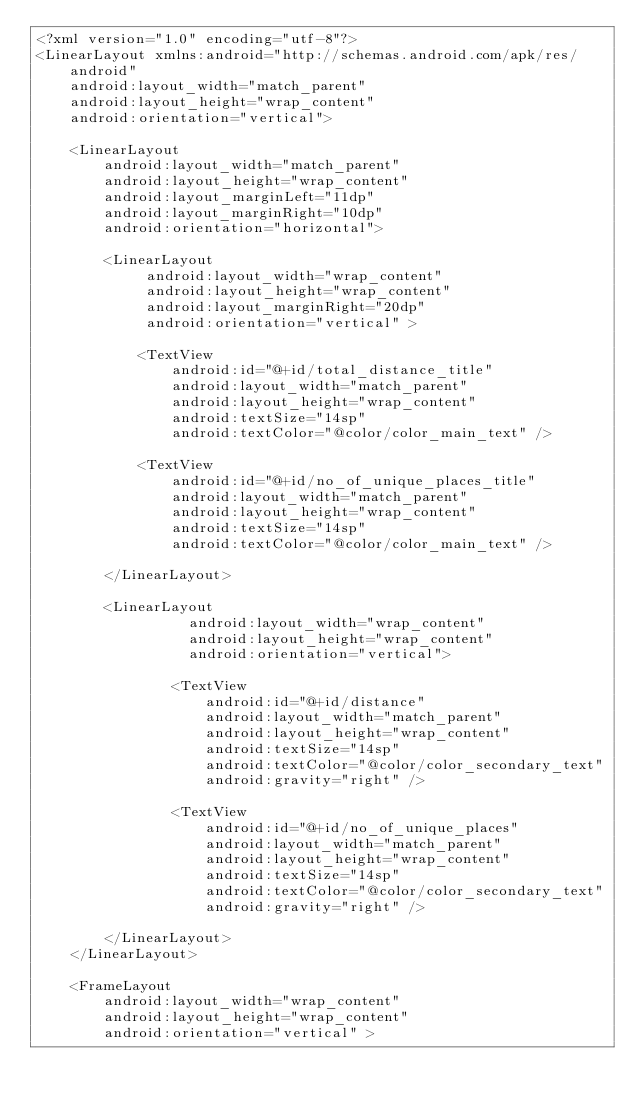<code> <loc_0><loc_0><loc_500><loc_500><_XML_><?xml version="1.0" encoding="utf-8"?>
<LinearLayout xmlns:android="http://schemas.android.com/apk/res/android"
    android:layout_width="match_parent"
    android:layout_height="wrap_content"
    android:orientation="vertical"> 

	<LinearLayout
	    android:layout_width="match_parent"
	    android:layout_height="wrap_content"	    
	    android:layout_marginLeft="11dp"
     	android:layout_marginRight="10dp"
	    android:orientation="horizontal">
	    
	    <LinearLayout
	         android:layout_width="wrap_content"
	         android:layout_height="wrap_content"
	         android:layout_marginRight="20dp"
	         android:orientation="vertical" >

      		<TextView
      		    android:id="@+id/total_distance_title"
      		    android:layout_width="match_parent"
      		    android:layout_height="wrap_content"
      		    android:textSize="14sp"
        		android:textColor="@color/color_main_text" />
      		
      		<TextView
      		    android:id="@+id/no_of_unique_places_title"
      		    android:layout_width="match_parent"
      		    android:layout_height="wrap_content"
      		    android:textSize="14sp"
        		android:textColor="@color/color_main_text" />
            
		</LinearLayout>

	    <LinearLayout
	              android:layout_width="wrap_content"
	              android:layout_height="wrap_content"
	              android:orientation="vertical">             
	      		            		      		
	      		<TextView
	        		android:id="@+id/distance"
	        		android:layout_width="match_parent"
	        		android:layout_height="wrap_content"
	        		android:textSize="14sp"
	        		android:textColor="@color/color_secondary_text"
	        		android:gravity="right" />
	      		
	      		<TextView
	        		android:id="@+id/no_of_unique_places"
	        		android:layout_width="match_parent"
	        		android:layout_height="wrap_content"
	        		android:textSize="14sp"
	        		android:textColor="@color/color_secondary_text"
	        		android:gravity="right" />	      	
	            
		</LinearLayout>	
	</LinearLayout>

	<FrameLayout
        android:layout_width="wrap_content"
        android:layout_height="wrap_content"
        android:orientation="vertical" >
	            </code> 